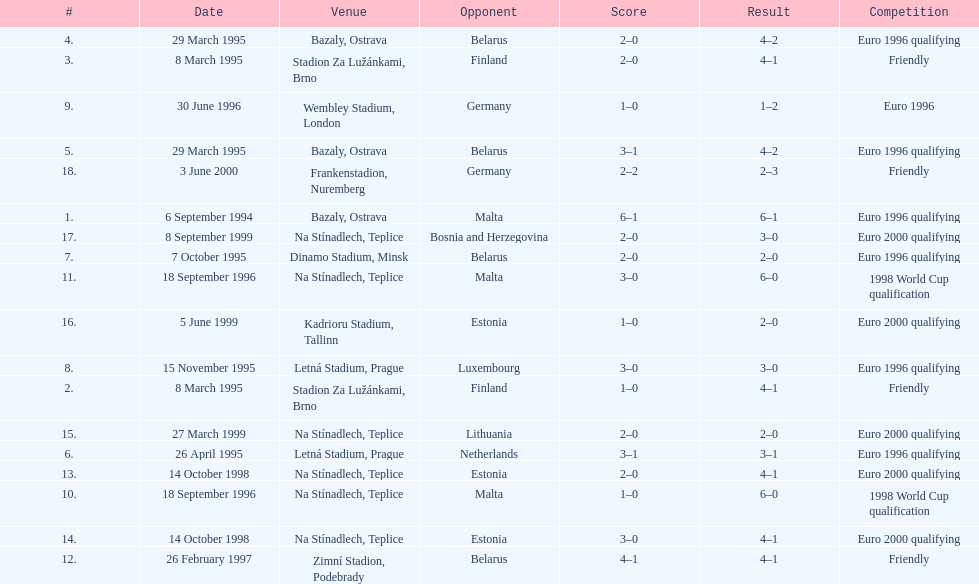How many times have the czech republic and germany faced each other in matches? 2. 